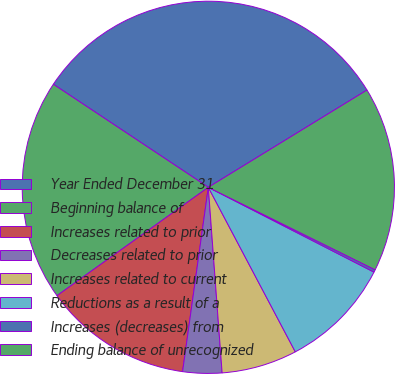Convert chart. <chart><loc_0><loc_0><loc_500><loc_500><pie_chart><fcel>Year Ended December 31<fcel>Beginning balance of<fcel>Increases related to prior<fcel>Decreases related to prior<fcel>Increases related to current<fcel>Reductions as a result of a<fcel>Increases (decreases) from<fcel>Ending balance of unrecognized<nl><fcel>31.91%<fcel>19.23%<fcel>12.9%<fcel>3.39%<fcel>6.56%<fcel>9.73%<fcel>0.22%<fcel>16.06%<nl></chart> 